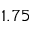<formula> <loc_0><loc_0><loc_500><loc_500>1 . 7 5</formula> 